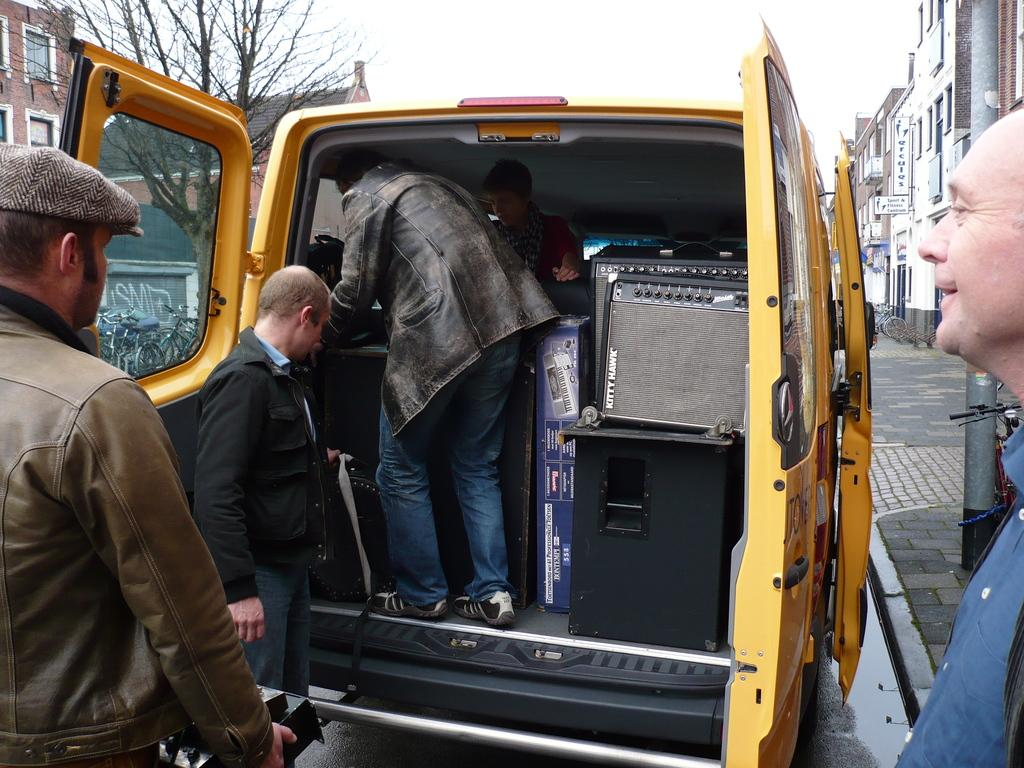How many people are on the road in the image? There are three persons on the road in the image. What else can be seen in the image besides the people on the road? There is a vehicle, sky, buildings, and a tree visible in the image. Can you describe the vehicle in the image? There is a vehicle in the image, and a person is standing inside it. What is the background of the image? The background of the image includes buildings and a tree. What type of cake is being served on the page in the image? There is no page or cake present in the image. Is the pencil used by any of the persons in the image? There is no pencil visible in the image. 